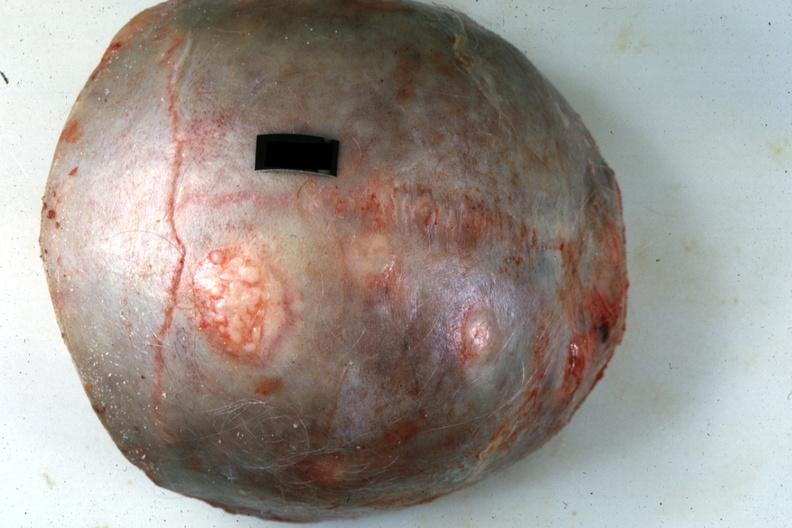does this image show skull cap with obvious metastatic lesions primary in pancreas?
Answer the question using a single word or phrase. Yes 